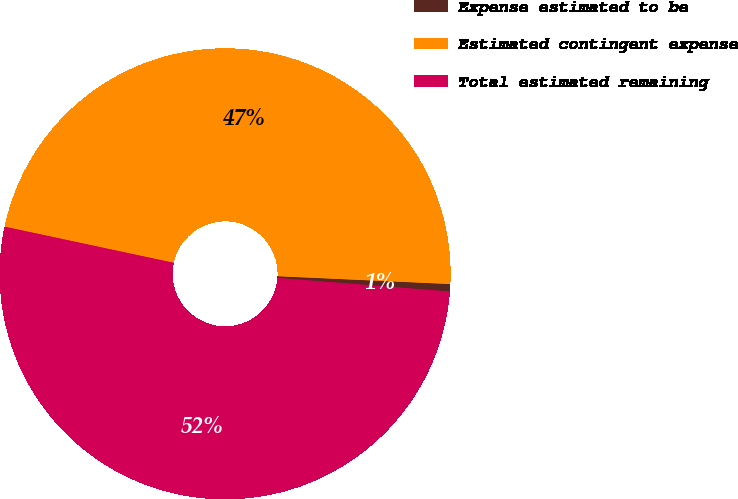Convert chart to OTSL. <chart><loc_0><loc_0><loc_500><loc_500><pie_chart><fcel>Expense estimated to be<fcel>Estimated contingent expense<fcel>Total estimated remaining<nl><fcel>0.53%<fcel>47.37%<fcel>52.1%<nl></chart> 